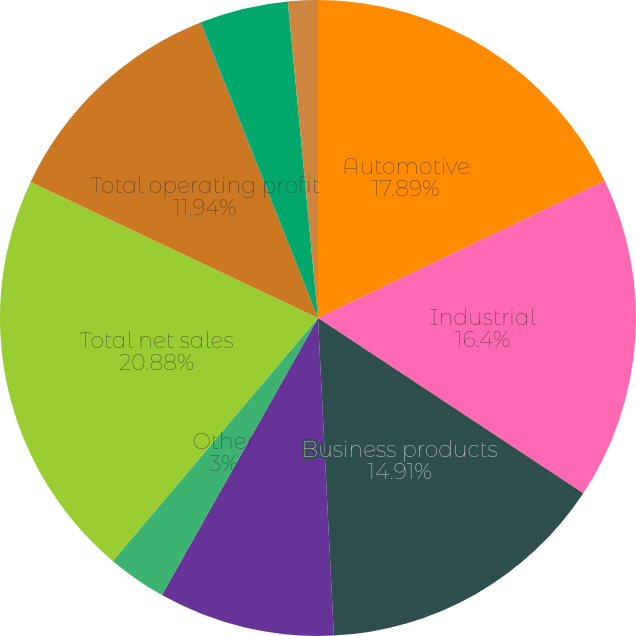Convert chart to OTSL. <chart><loc_0><loc_0><loc_500><loc_500><pie_chart><fcel>Automotive<fcel>Industrial<fcel>Business products<fcel>Electrical/electronic<fcel>Other<fcel>Total net sales<fcel>Total operating profit<fcel>Interest expense net<fcel>Corporate expense<fcel>Intangible asset amortization<nl><fcel>17.89%<fcel>16.4%<fcel>14.91%<fcel>8.96%<fcel>3.0%<fcel>20.87%<fcel>11.94%<fcel>0.02%<fcel>4.49%<fcel>1.51%<nl></chart> 